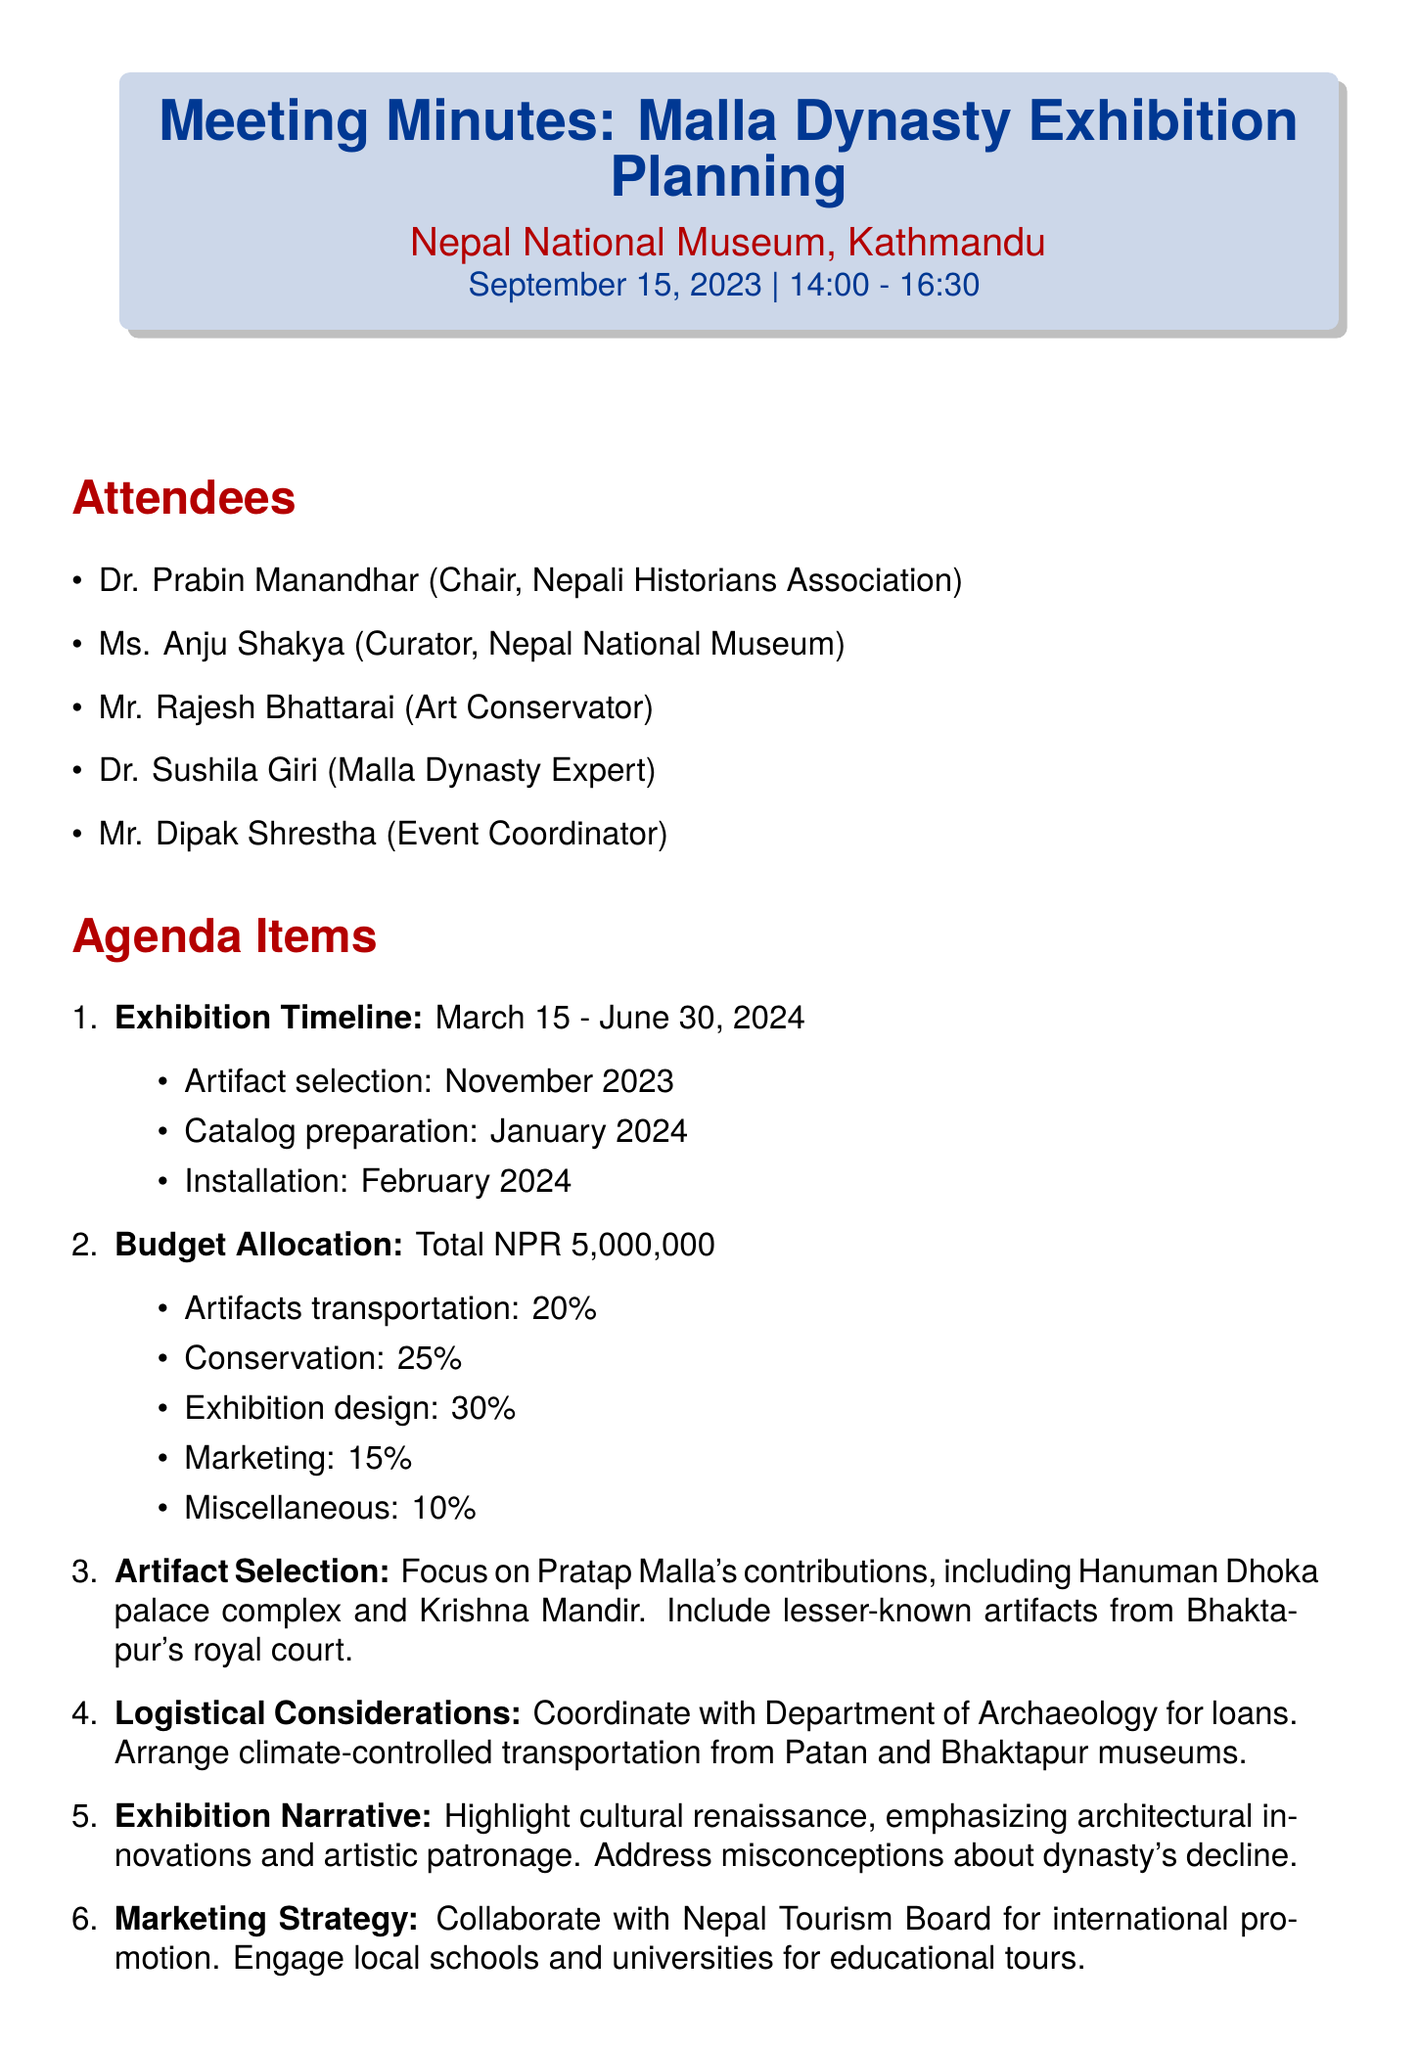what is the date of the meeting? The date of the meeting is explicitly mentioned in the document as September 15, 2023.
Answer: September 15, 2023 who is the chair of the meeting? The chair of the meeting is listed as Dr. Prabin Manandhar.
Answer: Dr. Prabin Manandhar what is the total budget for the exhibition? The total budget for the exhibition is stated as NPR 5,000,000.
Answer: NPR 5,000,000 when is the artifact selection scheduled? The document specifies that the artifact selection is proposed for November 2023.
Answer: November 2023 what percentage of the budget is allocated for exhibition design? The document details that 30% of the budget is allocated for exhibition design.
Answer: 30% which artifacts are focused on in the selection? It specifically mentions focusing on Pratap Malla's contributions, including the Hanuman Dhoka palace complex and Krishna Mandir.
Answer: Pratap Malla's contributions who is responsible for finalizing the artifact list? The action item specifies that Dr. Giri is to finalize the artifact list by October 31, 2023.
Answer: Dr. Giri what does the exhibition narrative aim to highlight? The exhibition narrative aims to highlight the cultural renaissance during the Malla period.
Answer: cultural renaissance during the Malla period how long is the exhibition planned to run? The proposed exhibition dates are from March 15 to June 30, 2024, indicating it runs for about 3 months.
Answer: March 15 - June 30, 2024 